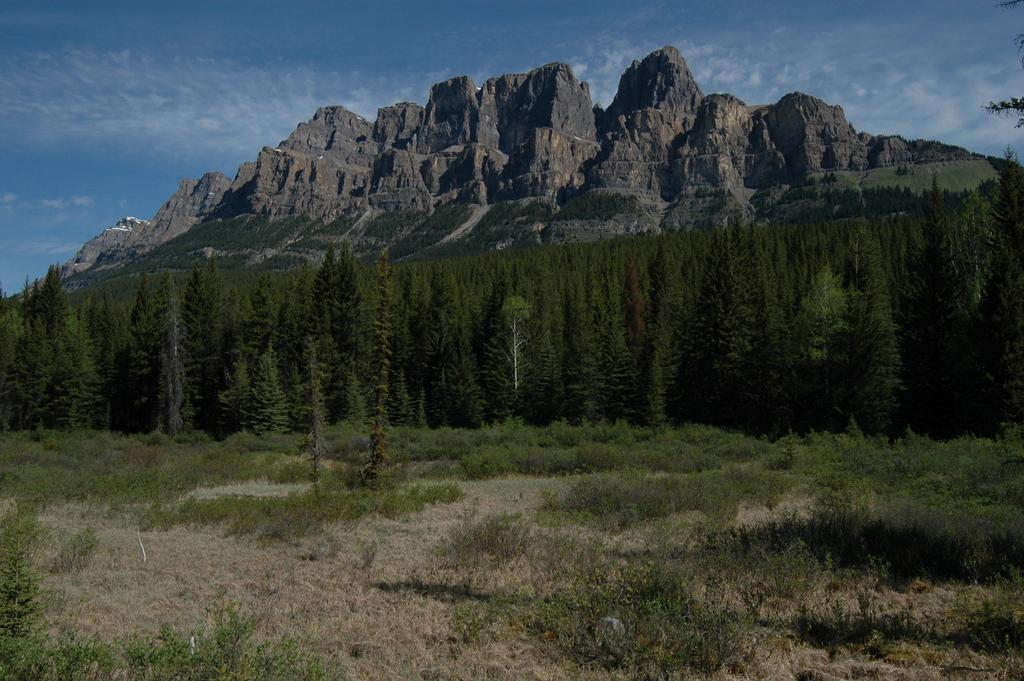Can you describe this image briefly? In the image we can see there is ground covered with grass and there are dry plants on the ground. Behind there are trees and there are rock hills. There is clear sky on the top. 